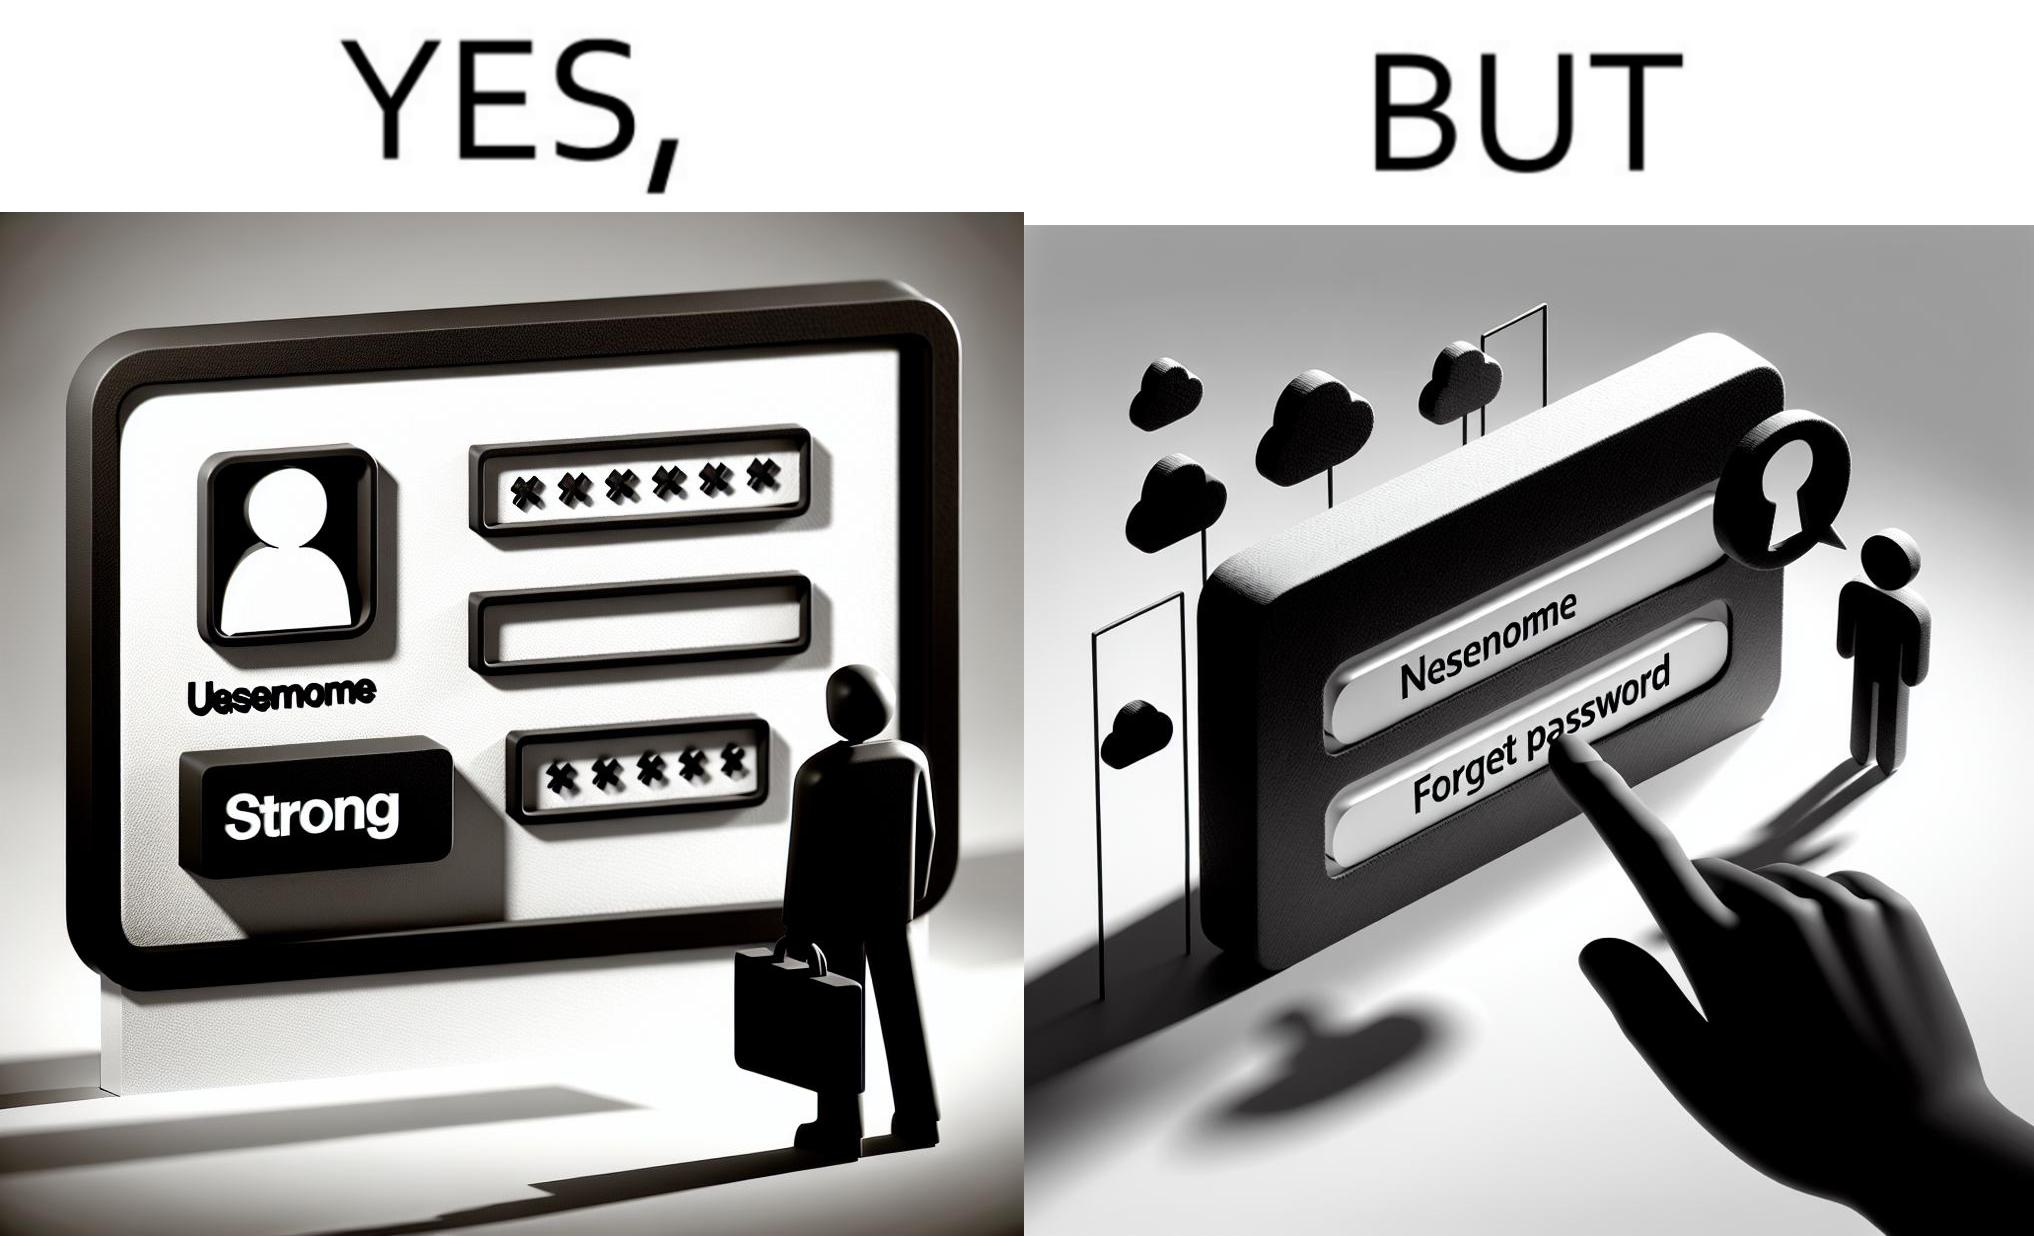Provide a description of this image. The image is ironic, because people set such a strong passwords for their accounts that they even forget the password and need to reset them 